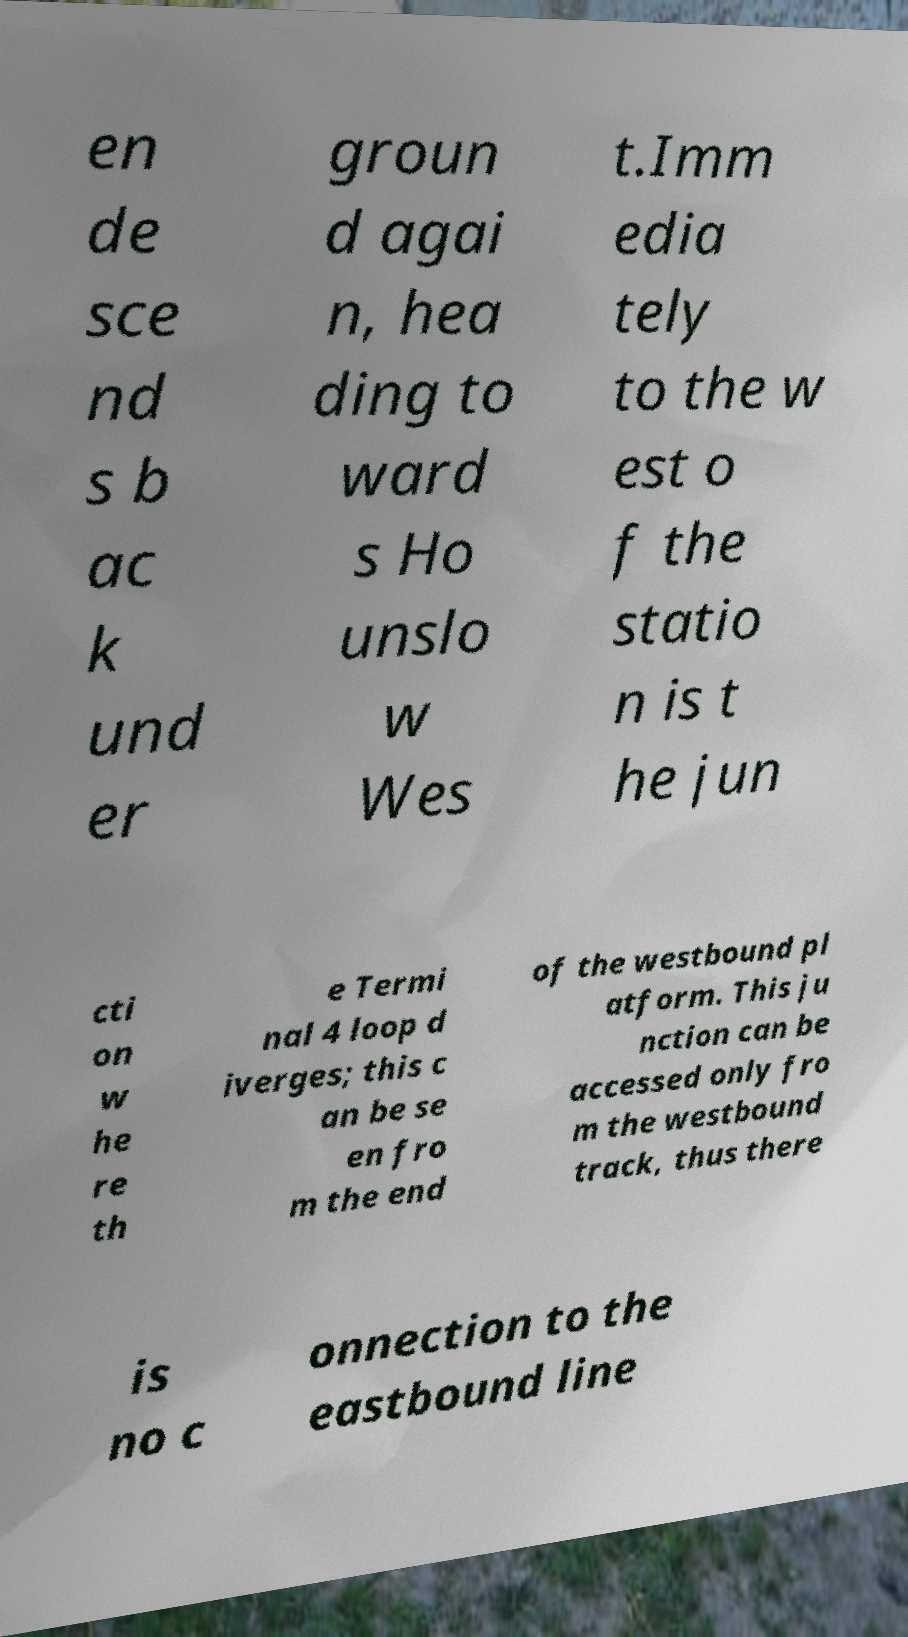Can you accurately transcribe the text from the provided image for me? en de sce nd s b ac k und er groun d agai n, hea ding to ward s Ho unslo w Wes t.Imm edia tely to the w est o f the statio n is t he jun cti on w he re th e Termi nal 4 loop d iverges; this c an be se en fro m the end of the westbound pl atform. This ju nction can be accessed only fro m the westbound track, thus there is no c onnection to the eastbound line 